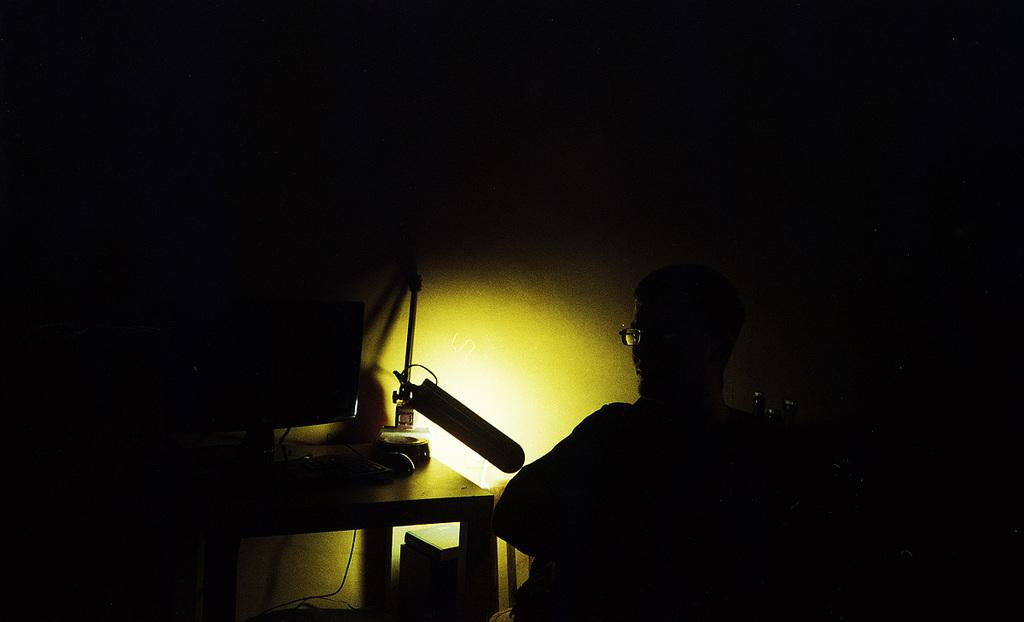What is the overall lighting condition in the image? The image is dark. Can you describe the person in the image? There is a person wearing specs in the image. What piece of furniture is present in the image? There is a table in the image. What electronic device is on the table? There is a computer on the table. What other items can be seen on the table? There are other items on the table. Can you describe the source of light in the image? There is light in the image. How many babies are crawling on the table in the image? There are no babies present in the image, and therefore no babies are crawling on the table. What type of detail can be seen on the computer screen in the image? There is no specific detail visible on the computer screen in the image, as the screen is not focused on or described in the provided facts. 